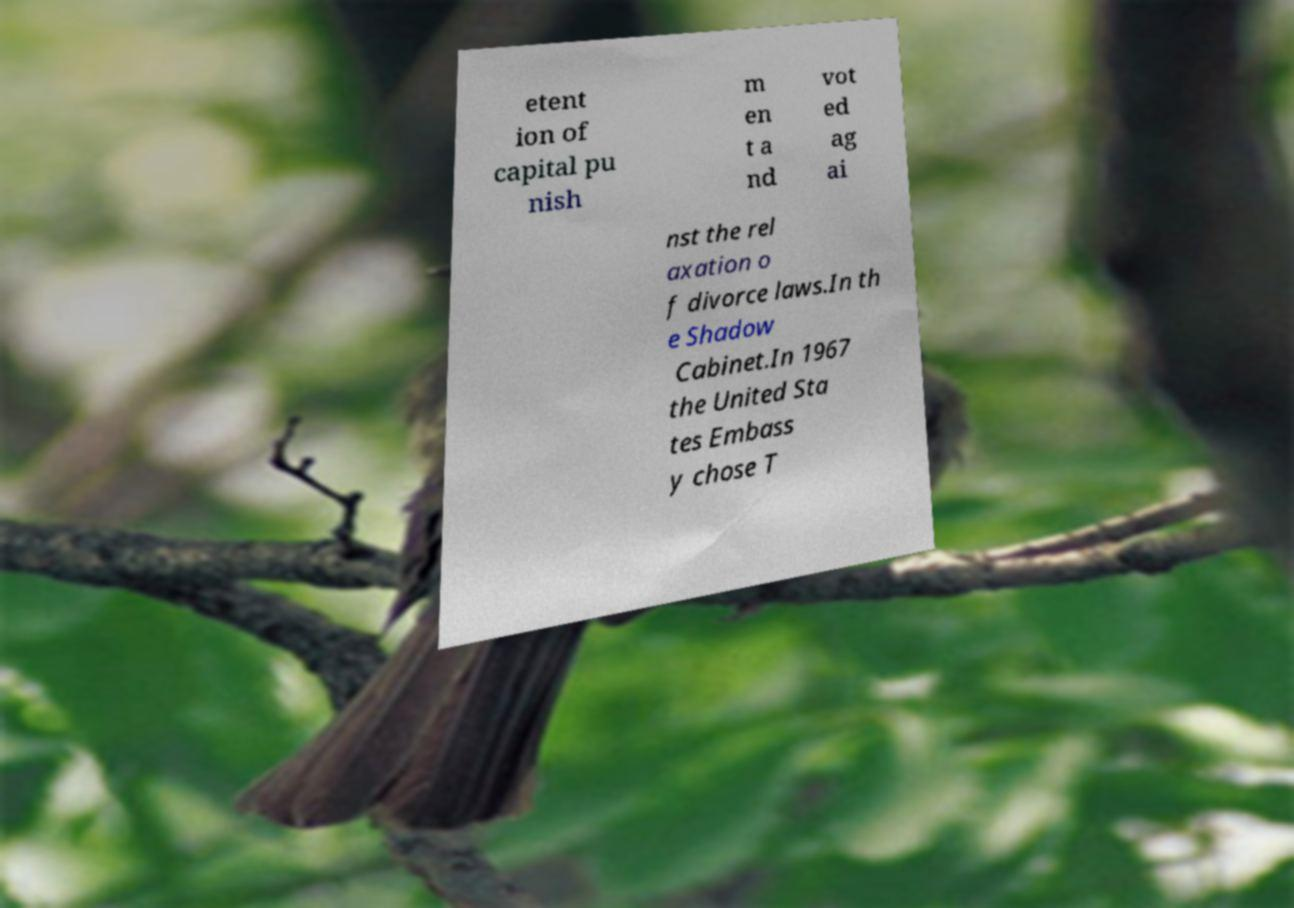What messages or text are displayed in this image? I need them in a readable, typed format. etent ion of capital pu nish m en t a nd vot ed ag ai nst the rel axation o f divorce laws.In th e Shadow Cabinet.In 1967 the United Sta tes Embass y chose T 